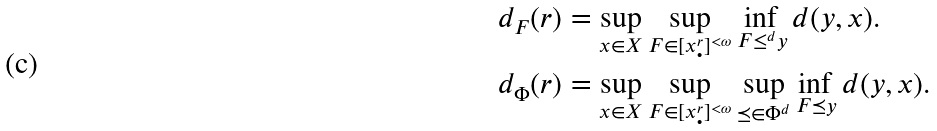Convert formula to latex. <formula><loc_0><loc_0><loc_500><loc_500>d _ { F } ( r ) & = \sup _ { x \in X } \sup _ { F \in [ x _ { \bullet } ^ { r } ] ^ { < \omega } } \inf _ { F \leq ^ { d } y } d ( y , x ) . \\ d _ { \Phi } ( r ) & = \sup _ { x \in X } \sup _ { F \in [ x _ { \bullet } ^ { r } ] ^ { < \omega } } \sup _ { \preceq \in \Phi ^ { d } } \inf _ { F \preceq y } d ( y , x ) .</formula> 